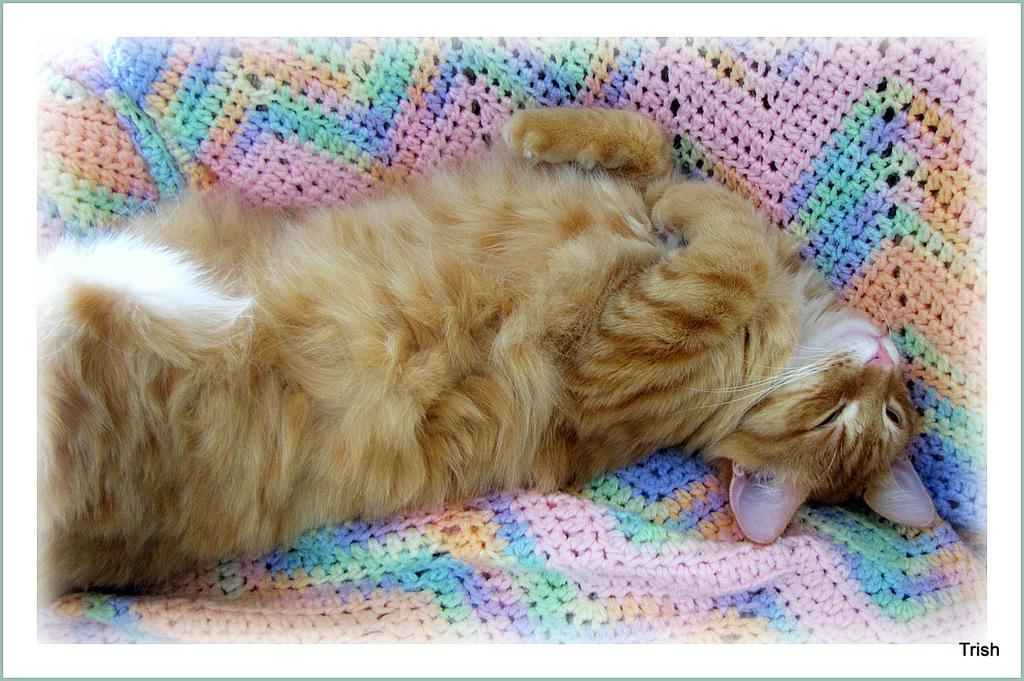What type of animal is present in the image? There is a cat in the image. What is the cat doing in the image? The cat is sleeping. What is the cat resting on in the image? The cat is on a blanket. What type of burn can be seen on the cat's paw in the image? There is no burn visible on the cat's paw in the image; the cat is simply sleeping on a blanket. 